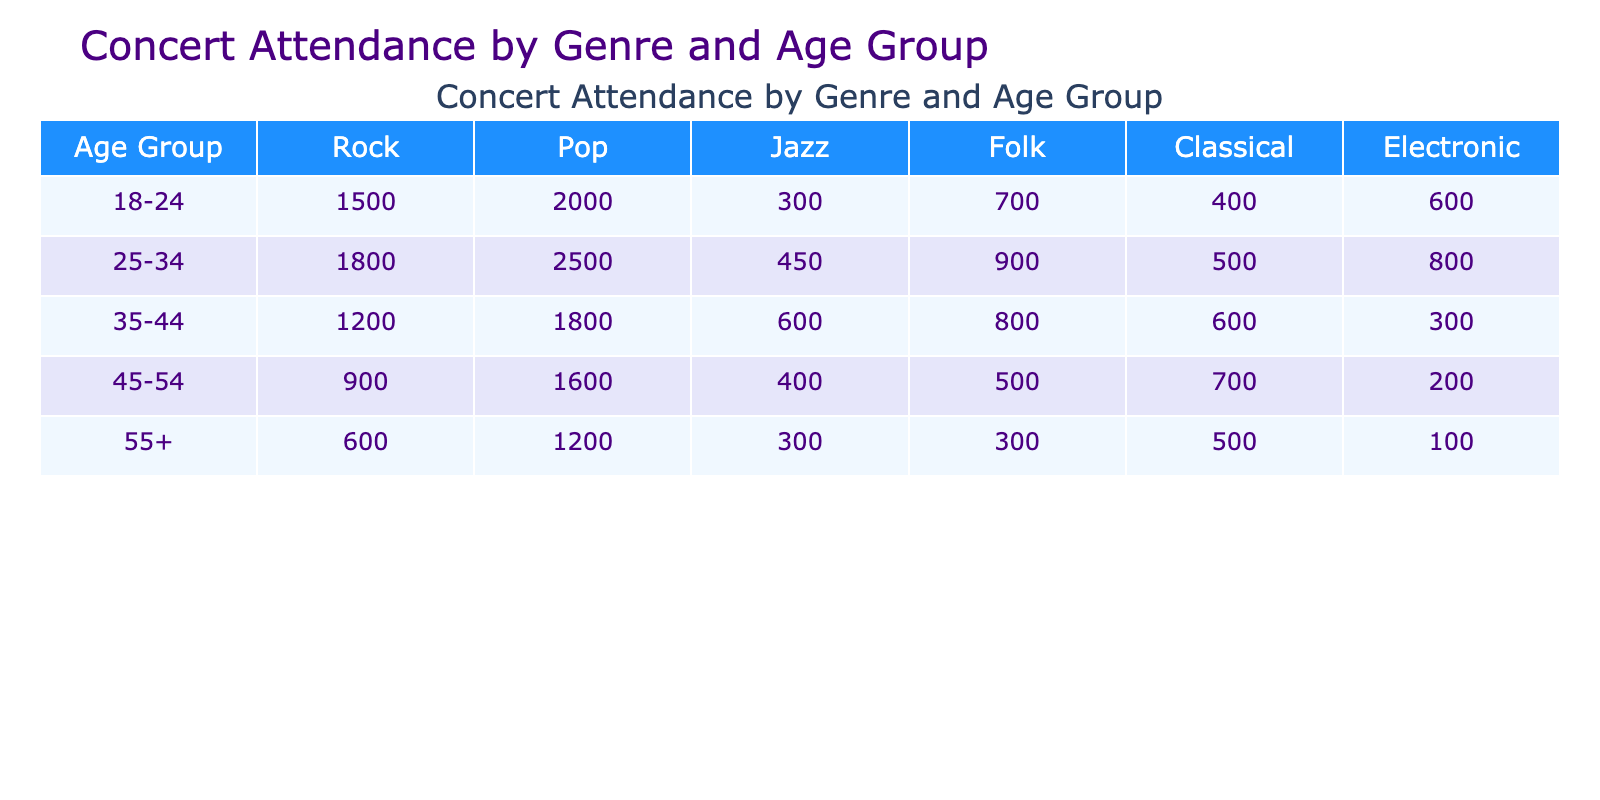What's the total concert attendance for the age group 18-24? The values for the age group 18-24 are 1500 for Rock, 2000 for Pop, 300 for Jazz, 700 for Folk, 400 for Classical, and 600 for Electronic. Adding these together gives 1500 + 2000 + 300 + 700 + 400 + 600 = 5100.
Answer: 5100 Which genre had the highest attendance among the 25-34 age group? In the 25-34 age group, the attendance values are 1800 for Rock, 2500 for Pop, 450 for Jazz, 900 for Folk, 500 for Classical, and 800 for Electronic. The highest value is 2500 for Pop.
Answer: Pop Is the attendance for Jazz among 35-44 year-olds greater than the attendance for Folk in the same age group? The attendance for Jazz in the 35-44 age group is 600, while for Folk it is 800. Since 600 is not greater than 800, the statement is false.
Answer: No What is the total concert attendance for older adults (55+)? The values for the age group 55+ are 600 for Rock, 1200 for Pop, 300 for Jazz, 300 for Folk, 500 for Classical, and 100 for Electronic. The total is 600 + 1200 + 300 + 300 + 500 + 100 = 3000.
Answer: 3000 Which age group has the least attendance for Classical music? The attendance for Classical music by age group is as follows: 400 (18-24), 500 (25-34), 600 (35-44), 700 (45-54), 500 (55+). The least attendance is 400 from the 18-24 age group.
Answer: 18-24 What is the difference in total attendance between the 45-54 and 55+ age groups across all genres? For the 45-54 age group, total attendance is 900 + 1600 + 400 + 500 + 700 + 200 = 4300. For the 55+ age group, total attendance is 600 + 1200 + 300 + 300 + 500 + 100 = 3000. The difference is 4300 - 3000 = 1300.
Answer: 1300 Does the 25-34 age group have higher total attendance than the 35-44 age group? Total attendance for the 25-34 age group is 1800 + 2500 + 450 + 900 + 500 + 800 = 6100. For the 35-44 age group, total attendance is 1200 + 1800 + 600 + 800 + 600 + 300 = 4300. Since 6100 is greater than 4300, the statement is true.
Answer: Yes What is the average concert attendance across all genres for the age group 45-54? The attendance values for the 45-54 age group are 900, 1600, 400, 500, 700, and 200. The total attendance is 4300, and there are 6 genres, so the average is 4300 / 6 = approximately 716.67.
Answer: 716.67 